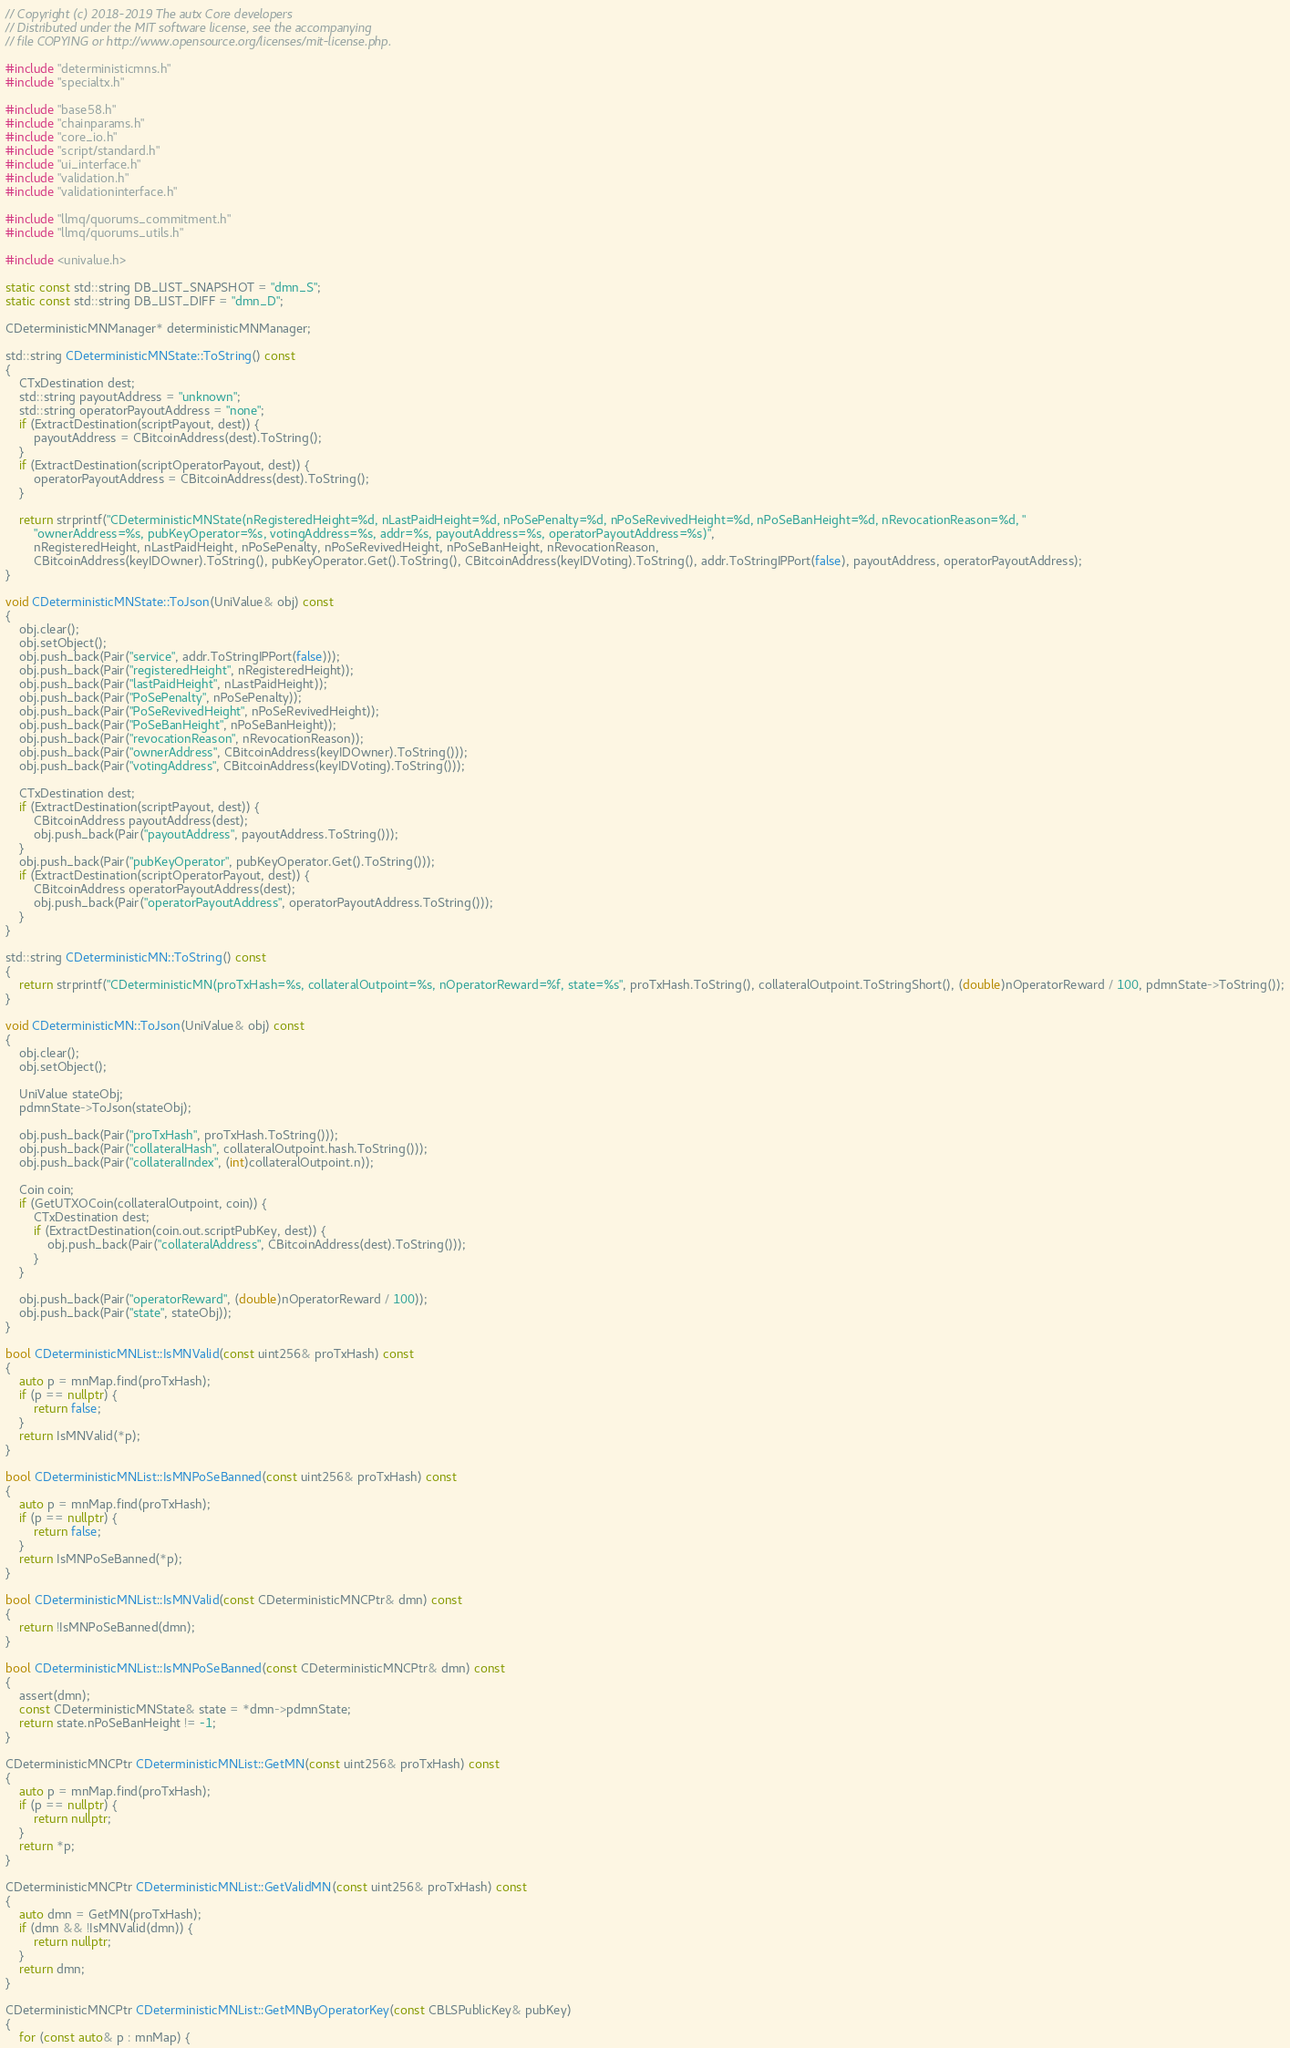<code> <loc_0><loc_0><loc_500><loc_500><_C++_>// Copyright (c) 2018-2019 The autx Core developers
// Distributed under the MIT software license, see the accompanying
// file COPYING or http://www.opensource.org/licenses/mit-license.php.

#include "deterministicmns.h"
#include "specialtx.h"

#include "base58.h"
#include "chainparams.h"
#include "core_io.h"
#include "script/standard.h"
#include "ui_interface.h"
#include "validation.h"
#include "validationinterface.h"

#include "llmq/quorums_commitment.h"
#include "llmq/quorums_utils.h"

#include <univalue.h>

static const std::string DB_LIST_SNAPSHOT = "dmn_S";
static const std::string DB_LIST_DIFF = "dmn_D";

CDeterministicMNManager* deterministicMNManager;

std::string CDeterministicMNState::ToString() const
{
    CTxDestination dest;
    std::string payoutAddress = "unknown";
    std::string operatorPayoutAddress = "none";
    if (ExtractDestination(scriptPayout, dest)) {
        payoutAddress = CBitcoinAddress(dest).ToString();
    }
    if (ExtractDestination(scriptOperatorPayout, dest)) {
        operatorPayoutAddress = CBitcoinAddress(dest).ToString();
    }

    return strprintf("CDeterministicMNState(nRegisteredHeight=%d, nLastPaidHeight=%d, nPoSePenalty=%d, nPoSeRevivedHeight=%d, nPoSeBanHeight=%d, nRevocationReason=%d, "
        "ownerAddress=%s, pubKeyOperator=%s, votingAddress=%s, addr=%s, payoutAddress=%s, operatorPayoutAddress=%s)",
        nRegisteredHeight, nLastPaidHeight, nPoSePenalty, nPoSeRevivedHeight, nPoSeBanHeight, nRevocationReason,
        CBitcoinAddress(keyIDOwner).ToString(), pubKeyOperator.Get().ToString(), CBitcoinAddress(keyIDVoting).ToString(), addr.ToStringIPPort(false), payoutAddress, operatorPayoutAddress);
}

void CDeterministicMNState::ToJson(UniValue& obj) const
{
    obj.clear();
    obj.setObject();
    obj.push_back(Pair("service", addr.ToStringIPPort(false)));
    obj.push_back(Pair("registeredHeight", nRegisteredHeight));
    obj.push_back(Pair("lastPaidHeight", nLastPaidHeight));
    obj.push_back(Pair("PoSePenalty", nPoSePenalty));
    obj.push_back(Pair("PoSeRevivedHeight", nPoSeRevivedHeight));
    obj.push_back(Pair("PoSeBanHeight", nPoSeBanHeight));
    obj.push_back(Pair("revocationReason", nRevocationReason));
    obj.push_back(Pair("ownerAddress", CBitcoinAddress(keyIDOwner).ToString()));
    obj.push_back(Pair("votingAddress", CBitcoinAddress(keyIDVoting).ToString()));

    CTxDestination dest;
    if (ExtractDestination(scriptPayout, dest)) {
        CBitcoinAddress payoutAddress(dest);
        obj.push_back(Pair("payoutAddress", payoutAddress.ToString()));
    }
    obj.push_back(Pair("pubKeyOperator", pubKeyOperator.Get().ToString()));
    if (ExtractDestination(scriptOperatorPayout, dest)) {
        CBitcoinAddress operatorPayoutAddress(dest);
        obj.push_back(Pair("operatorPayoutAddress", operatorPayoutAddress.ToString()));
    }
}

std::string CDeterministicMN::ToString() const
{
    return strprintf("CDeterministicMN(proTxHash=%s, collateralOutpoint=%s, nOperatorReward=%f, state=%s", proTxHash.ToString(), collateralOutpoint.ToStringShort(), (double)nOperatorReward / 100, pdmnState->ToString());
}

void CDeterministicMN::ToJson(UniValue& obj) const
{
    obj.clear();
    obj.setObject();

    UniValue stateObj;
    pdmnState->ToJson(stateObj);

    obj.push_back(Pair("proTxHash", proTxHash.ToString()));
    obj.push_back(Pair("collateralHash", collateralOutpoint.hash.ToString()));
    obj.push_back(Pair("collateralIndex", (int)collateralOutpoint.n));

    Coin coin;
    if (GetUTXOCoin(collateralOutpoint, coin)) {
        CTxDestination dest;
        if (ExtractDestination(coin.out.scriptPubKey, dest)) {
            obj.push_back(Pair("collateralAddress", CBitcoinAddress(dest).ToString()));
        }
    }

    obj.push_back(Pair("operatorReward", (double)nOperatorReward / 100));
    obj.push_back(Pair("state", stateObj));
}

bool CDeterministicMNList::IsMNValid(const uint256& proTxHash) const
{
    auto p = mnMap.find(proTxHash);
    if (p == nullptr) {
        return false;
    }
    return IsMNValid(*p);
}

bool CDeterministicMNList::IsMNPoSeBanned(const uint256& proTxHash) const
{
    auto p = mnMap.find(proTxHash);
    if (p == nullptr) {
        return false;
    }
    return IsMNPoSeBanned(*p);
}

bool CDeterministicMNList::IsMNValid(const CDeterministicMNCPtr& dmn) const
{
    return !IsMNPoSeBanned(dmn);
}

bool CDeterministicMNList::IsMNPoSeBanned(const CDeterministicMNCPtr& dmn) const
{
    assert(dmn);
    const CDeterministicMNState& state = *dmn->pdmnState;
    return state.nPoSeBanHeight != -1;
}

CDeterministicMNCPtr CDeterministicMNList::GetMN(const uint256& proTxHash) const
{
    auto p = mnMap.find(proTxHash);
    if (p == nullptr) {
        return nullptr;
    }
    return *p;
}

CDeterministicMNCPtr CDeterministicMNList::GetValidMN(const uint256& proTxHash) const
{
    auto dmn = GetMN(proTxHash);
    if (dmn && !IsMNValid(dmn)) {
        return nullptr;
    }
    return dmn;
}

CDeterministicMNCPtr CDeterministicMNList::GetMNByOperatorKey(const CBLSPublicKey& pubKey)
{
    for (const auto& p : mnMap) {</code> 